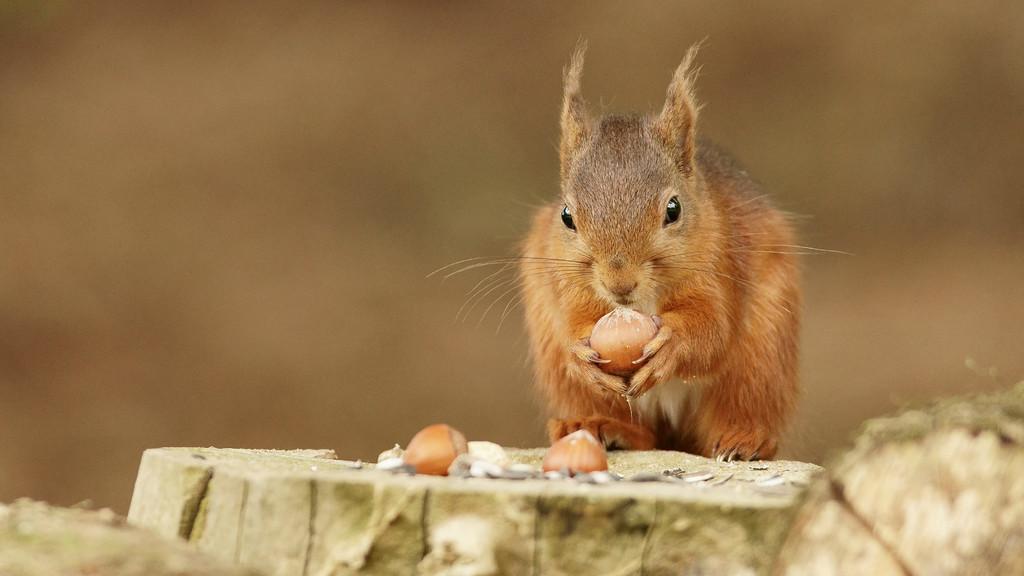Describe this image in one or two sentences. This picture seems to be clicked outside. In the foreground we can see some objects and we can see the food items. In the center there is an animal holding the food item and standing. The background of the image is blurry. 